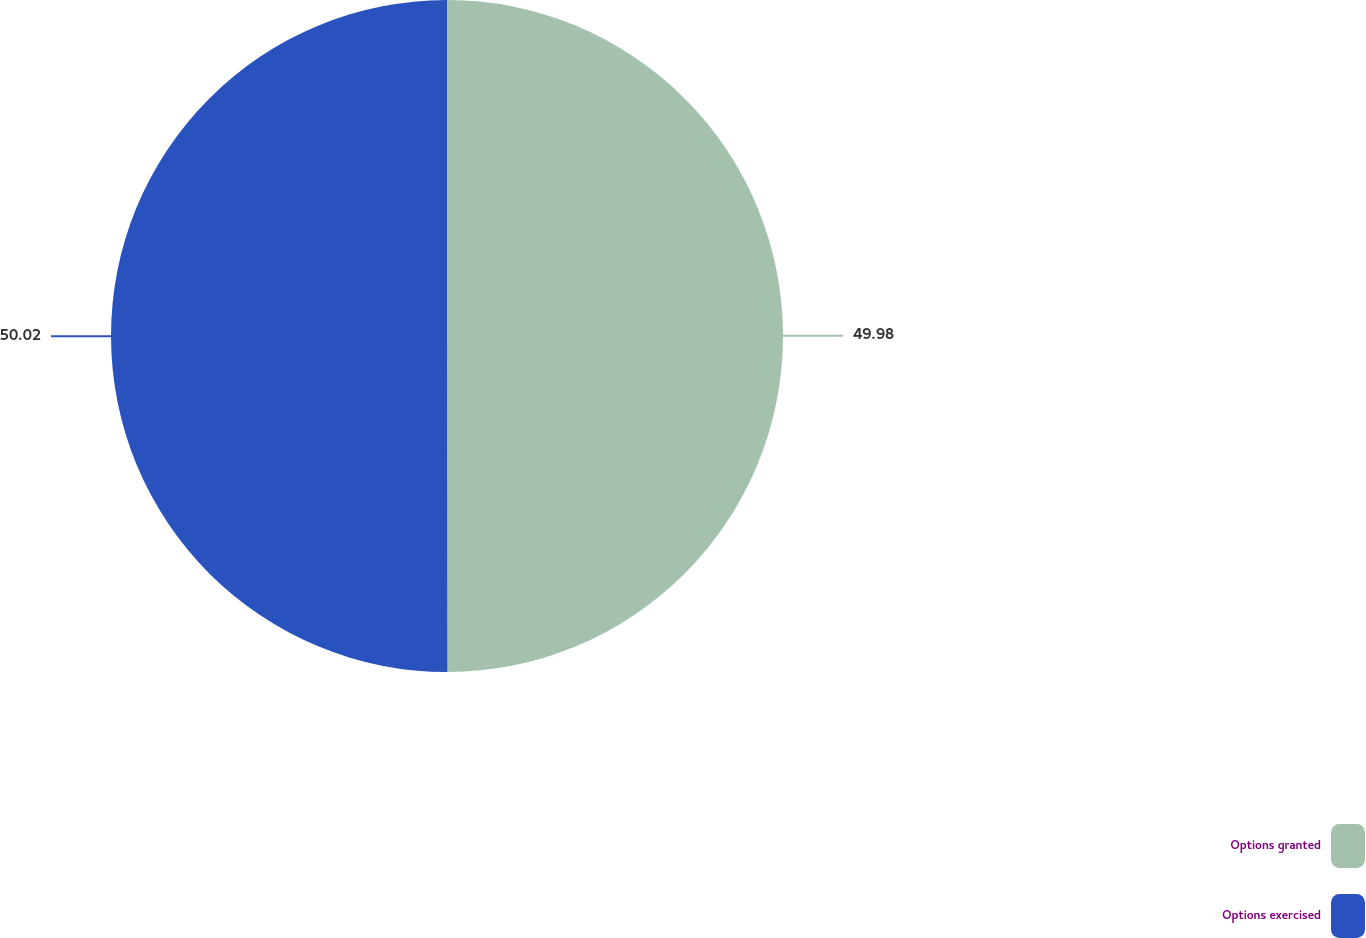Convert chart to OTSL. <chart><loc_0><loc_0><loc_500><loc_500><pie_chart><fcel>Options granted<fcel>Options exercised<nl><fcel>49.98%<fcel>50.02%<nl></chart> 